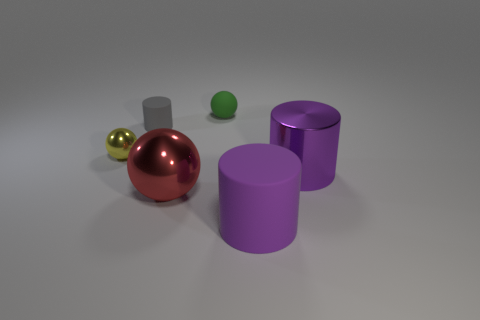Subtract all purple rubber cylinders. How many cylinders are left? 2 Subtract all brown blocks. How many purple cylinders are left? 2 Add 1 rubber spheres. How many objects exist? 7 Subtract all yellow spheres. How many spheres are left? 2 Subtract 1 spheres. How many spheres are left? 2 Subtract all yellow cylinders. Subtract all green cubes. How many cylinders are left? 3 Subtract all cyan blocks. Subtract all purple things. How many objects are left? 4 Add 6 purple cylinders. How many purple cylinders are left? 8 Add 3 green cubes. How many green cubes exist? 3 Subtract 0 gray spheres. How many objects are left? 6 